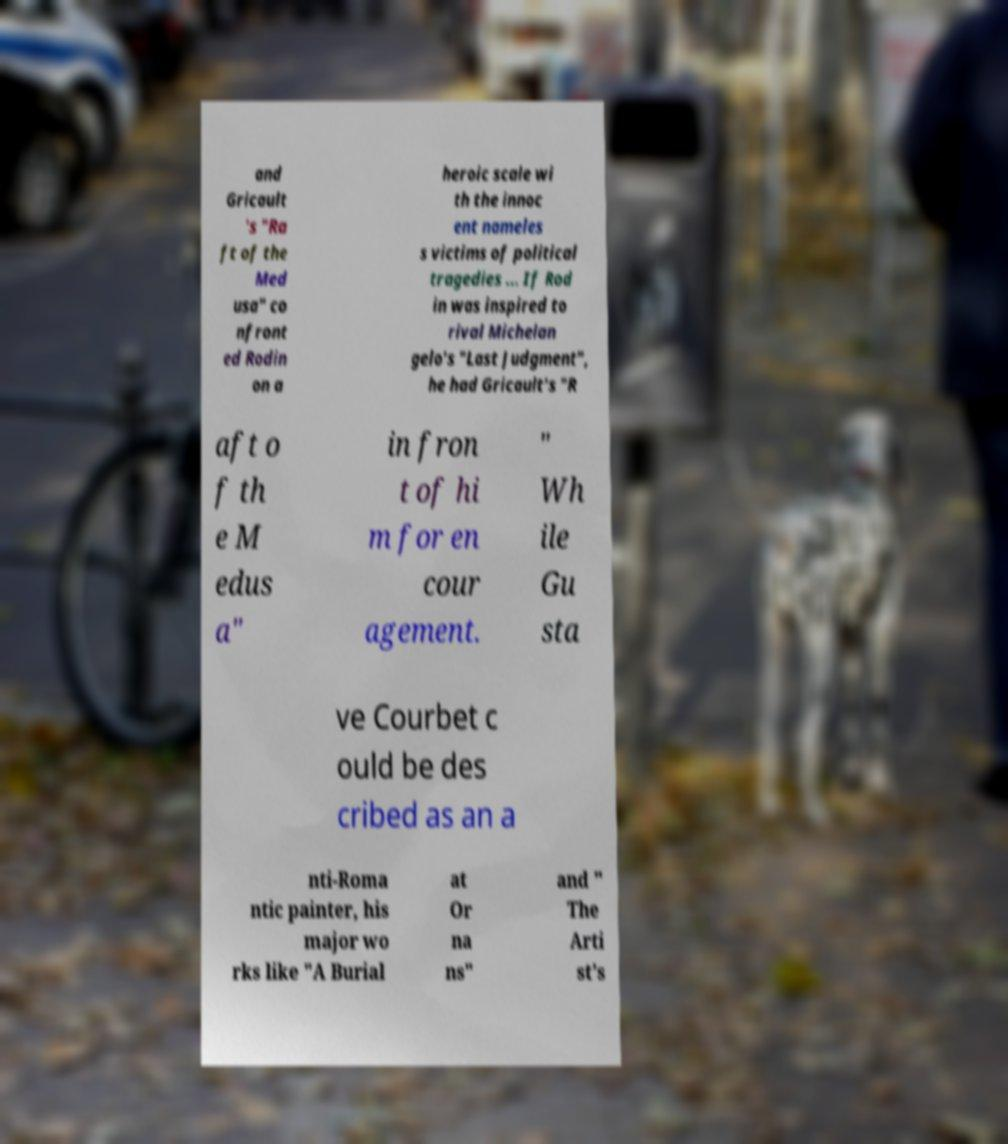What messages or text are displayed in this image? I need them in a readable, typed format. and Gricault 's "Ra ft of the Med usa" co nfront ed Rodin on a heroic scale wi th the innoc ent nameles s victims of political tragedies ... If Rod in was inspired to rival Michelan gelo's "Last Judgment", he had Gricault's "R aft o f th e M edus a" in fron t of hi m for en cour agement. " Wh ile Gu sta ve Courbet c ould be des cribed as an a nti-Roma ntic painter, his major wo rks like "A Burial at Or na ns" and " The Arti st's 